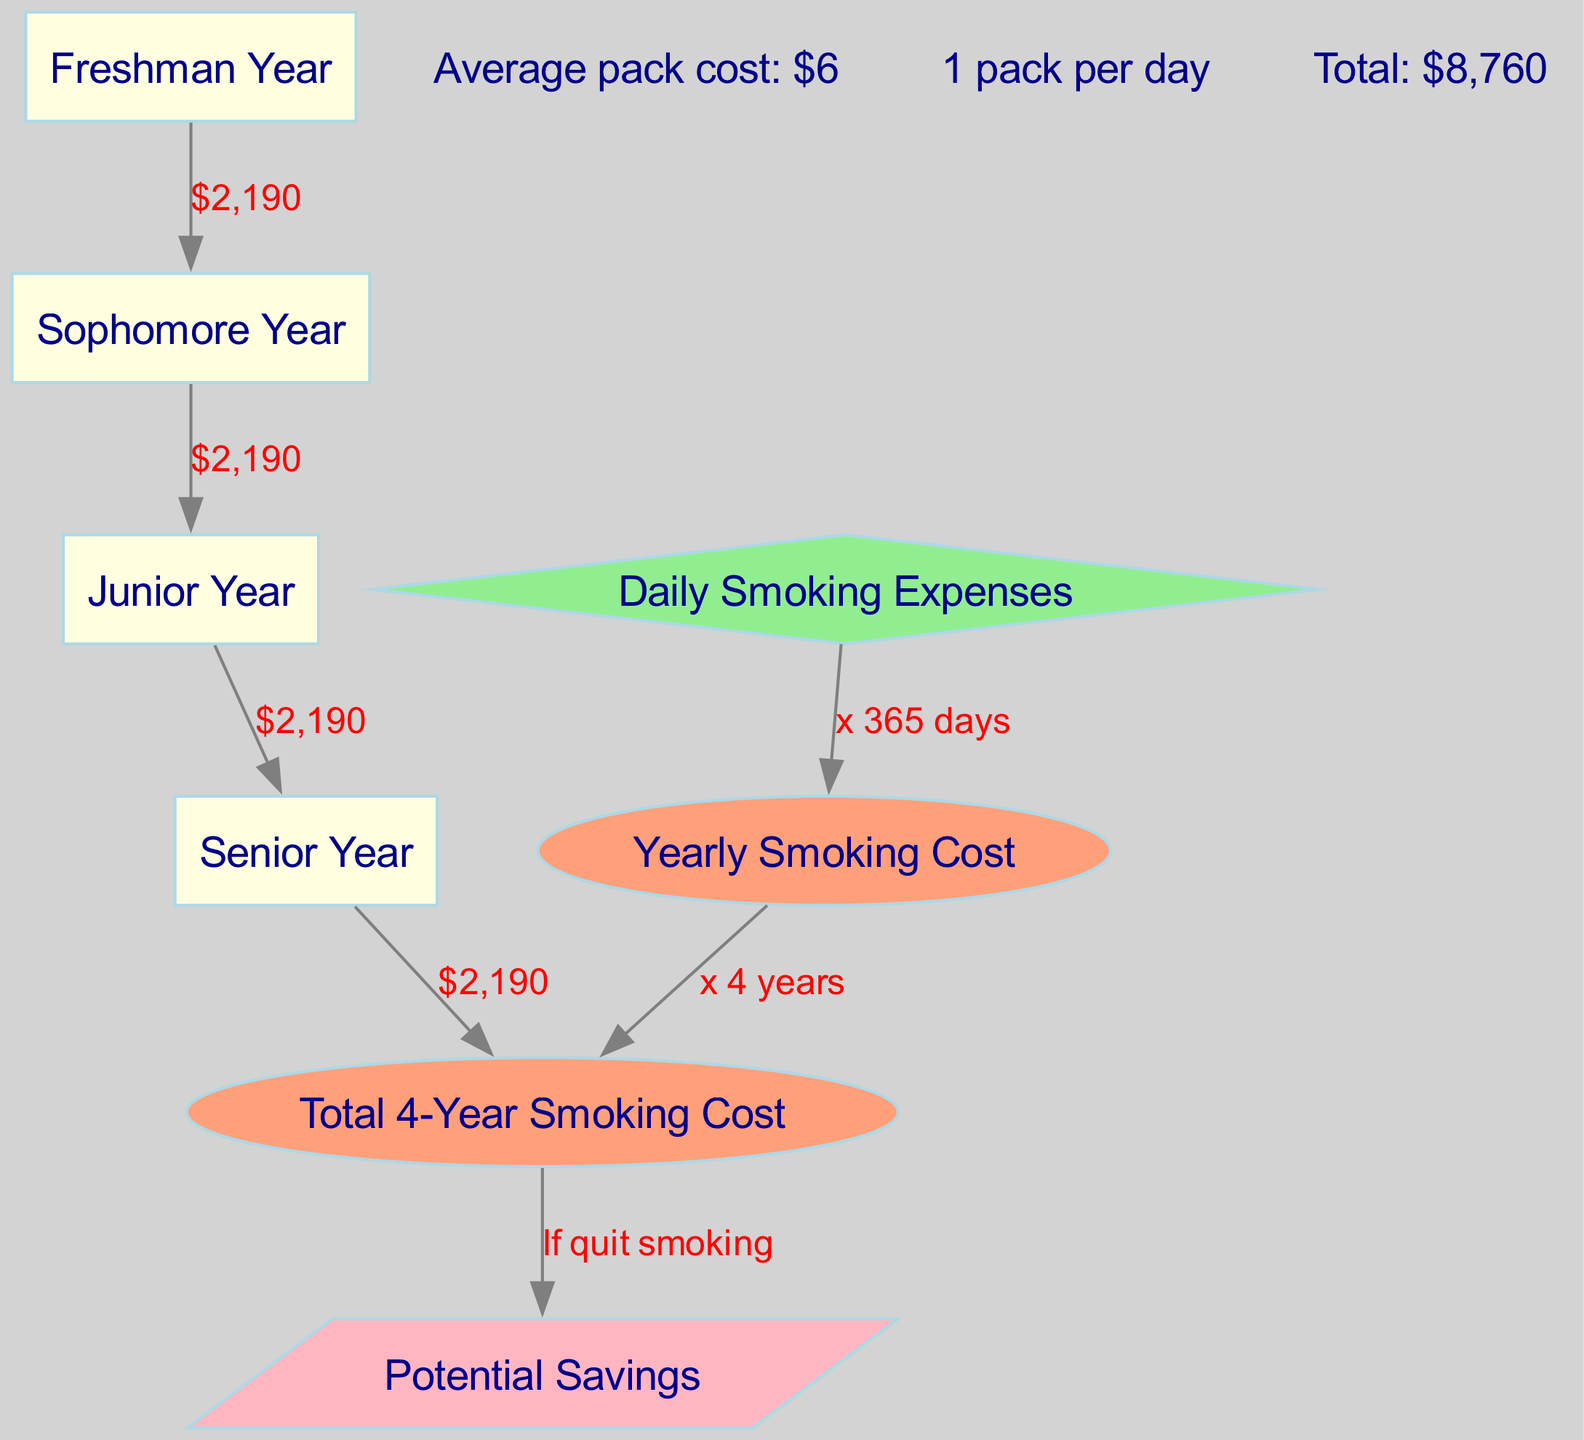what's the total yearly smoking cost for a college student? The yearly smoking cost is derived from the edges leading from the Freshman Year to the Senior Year, each indicating a cost of $2,190. Hence, the total yearly smoking cost is $2,190.
Answer: $2,190 how much does smoking cost per pack? The diagram includes an annotation that specifies the average pack cost as $6. Thus, the cost per pack of cigarettes is clearly indicated.
Answer: $6 what is the total cost of smoking over four years? The total smoking cost can be determined by the edge that connects the Senior Year to the Total 4-Year Smoking Cost, which indicates a value of $8,760. This value is also the sum of $2,190 for each of the four years.
Answer: $8,760 how many edges are in this flowchart? By counting the connections (edges) in the diagram, we find there are a total of 7 edges connecting the various nodes representing the financial impact of smoking over four years.
Answer: 7 what would be the potential savings if a student quit smoking? The potential savings are indicated on the diagram as a consequence of quitting smoking, which is represented as the next step after the total 4-Year Smoking Cost. Though the exact amount isn't stated, it's understood to be equal to the total smoking cost.
Answer: Total 4-Year Smoking Cost what is the daily smoking expense based on the flowchart? The daily smoking expense is represented as the node connected to the yearly cost calculations, where it implies a consistent daily cost as part of the annual budget. The diagram does not state the daily smoking expense directly, but it implies a significant expense across days.
Answer: Daily cost implied how many years does the diagram cover? The flowchart tracks a college student's finances over four academic years, from Freshman to Senior Year, indicating a period of 4 years for analysis.
Answer: 4 years how is the yearly smoking cost calculated according to the flowchart? The yearly smoking cost is calculated by taking the daily smoking expenses, which are multiplied by the number of days in a year (365 days), leading to an annual expense of $2,190 according to the edges transitioning from Daily Smoking Expenses to Yearly Smoking Cost.
Answer: Daily smoking expenses x 365 days what happens if a college student quits smoking based on the flowchart? The diagram suggests that if a student quits smoking, they would potentially save the total smoking costs evidenced by the connection from the Total 4-Year Smoking Cost to the Potential Savings node. This indicates a financial benefit from the choice to quit.
Answer: Potential savings indicated 